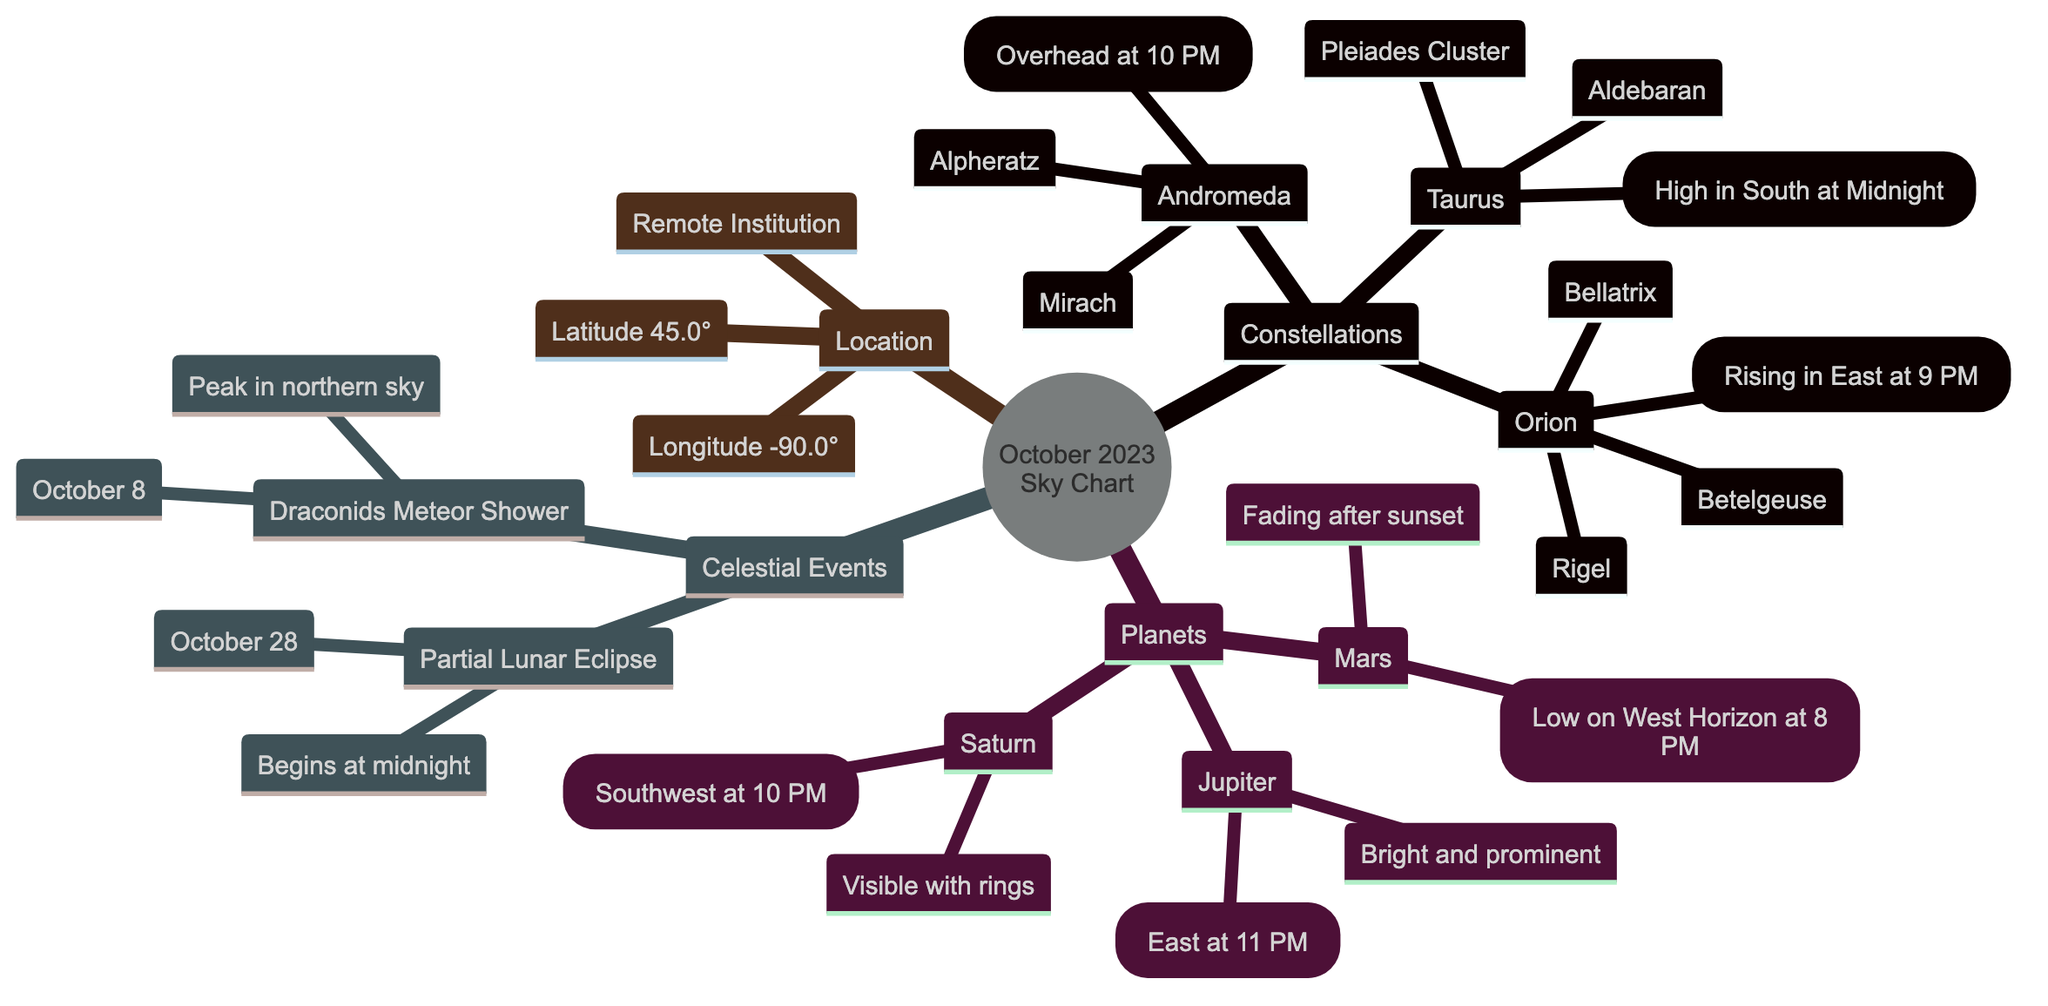What are the notable constellations visible in October 2023? The diagram lists four notable constellations: Orion, Taurus, Andromeda.
Answer: Orion, Taurus, Andromeda What is the position of Jupiter at 11 PM? According to the diagram, Jupiter is located in the East at 11 PM.
Answer: East How high is Taurus in the sky at midnight? The diagram indicates that Taurus is high in the South at Midnight.
Answer: High in South What date does the Draconids Meteor Shower peak? The diagram specifies that the Draconids Meteor Shower peaks on October 8.
Answer: October 8 What time does the Partial Lunar Eclipse begin? The diagram states that the Partial Lunar Eclipse begins at midnight.
Answer: Midnight Which planet is described as fading after sunset? From the diagram, Mars is noted to be fading after sunset.
Answer: Mars Where is the remote institution located based on the diagram? The diagram provides the coordinates for the remote institution, which is at Latitude 45.0° and Longitude -90.0°.
Answer: Latitude 45.0° and Longitude -90.0° Which constellation features the Pleiades Cluster? The diagram indicates that the Pleiades Cluster is part of the Taurus constellation.
Answer: Taurus What is the visible feature of Saturn at 10 PM? According to the diagram, Saturn is noted as being visible with rings at 10 PM.
Answer: Visible with rings What star is the brightest in Orion? The diagram identifies Betelgeuse as the brightest star in the Orion constellation.
Answer: Betelgeuse 